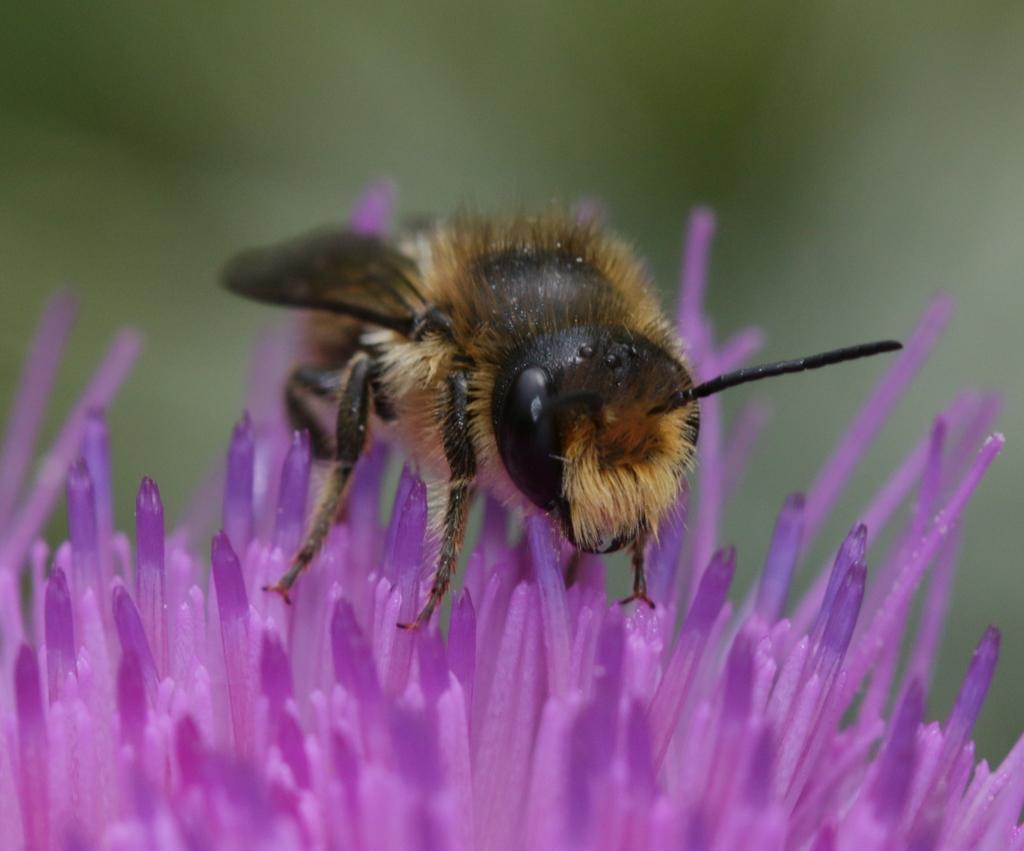Can you describe this image briefly? Here we can see an insect on a flower. There is a blur background. 